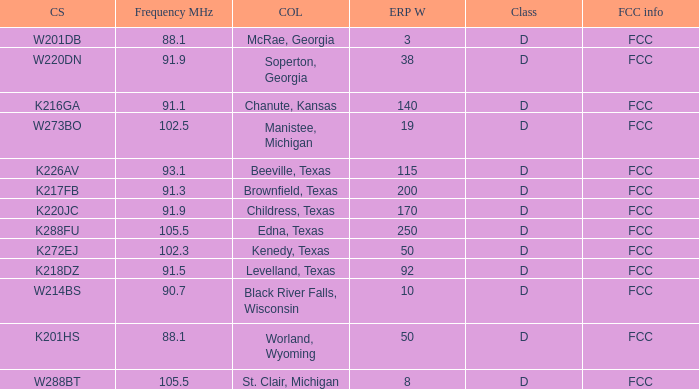What is Call Sign, when City of License is Brownfield, Texas? K217FB. 